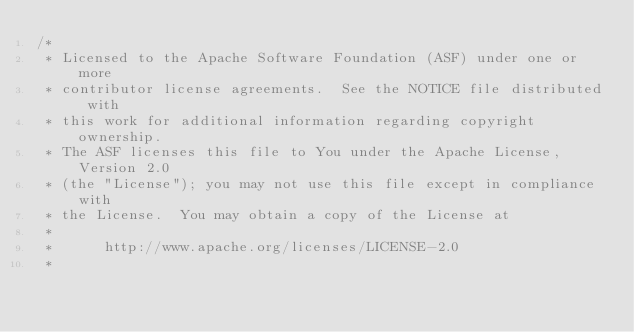<code> <loc_0><loc_0><loc_500><loc_500><_Java_>/*
 * Licensed to the Apache Software Foundation (ASF) under one or more
 * contributor license agreements.  See the NOTICE file distributed with
 * this work for additional information regarding copyright ownership.
 * The ASF licenses this file to You under the Apache License, Version 2.0
 * (the "License"); you may not use this file except in compliance with
 * the License.  You may obtain a copy of the License at
 *
 *      http://www.apache.org/licenses/LICENSE-2.0
 *</code> 